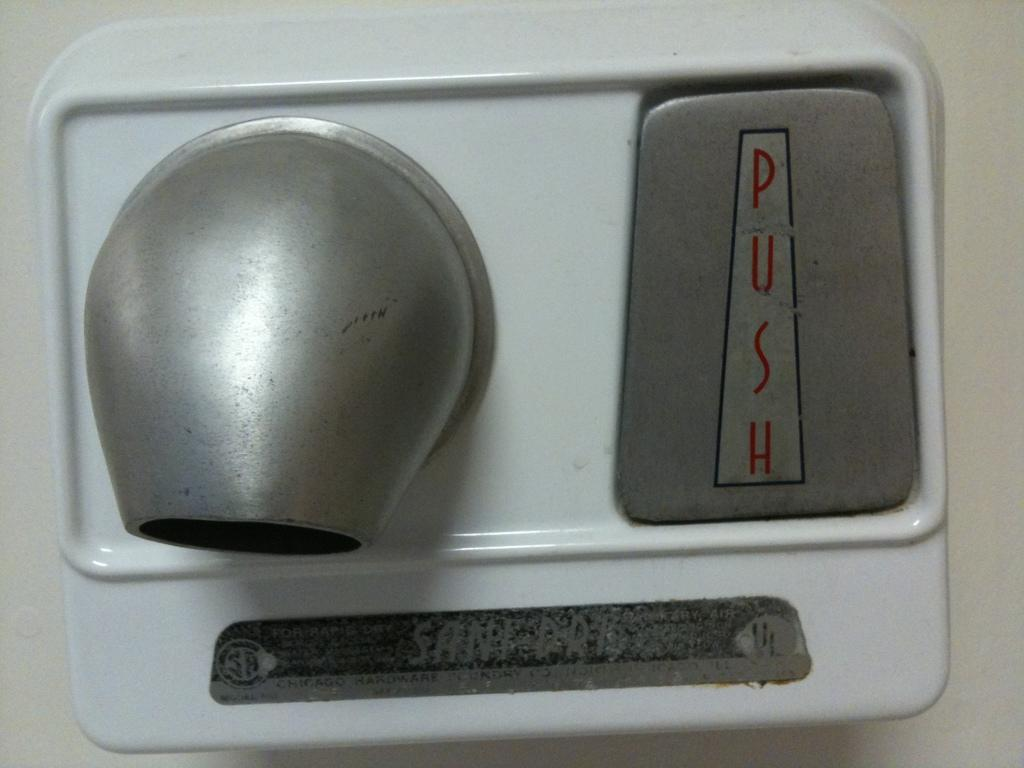<image>
Give a short and clear explanation of the subsequent image. Blow dryer with a button that says PUSH on the side. 